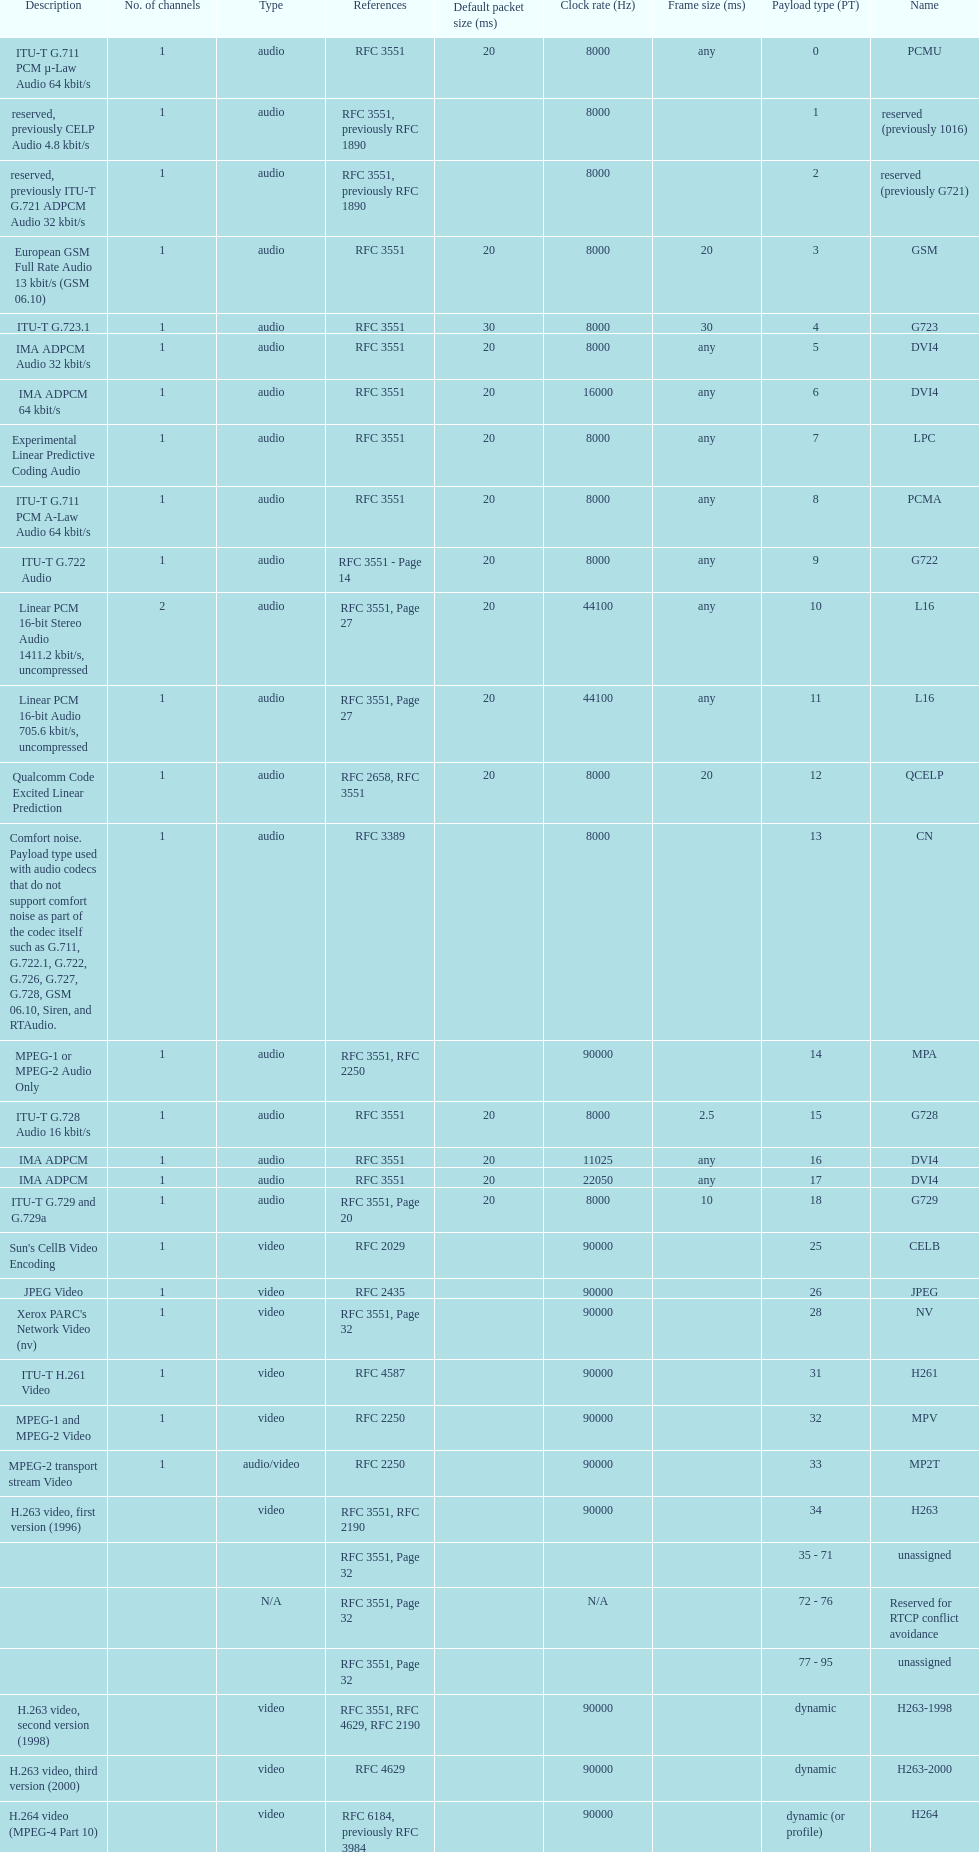Other than audio, what type of payload types are there? Video. 